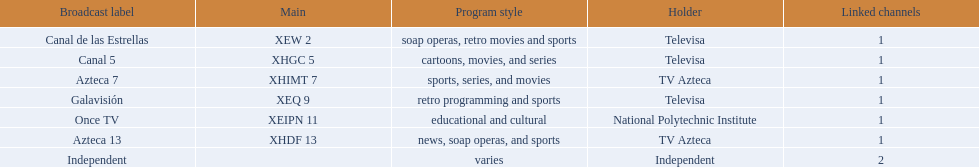How many networks do not air sports? 2. 